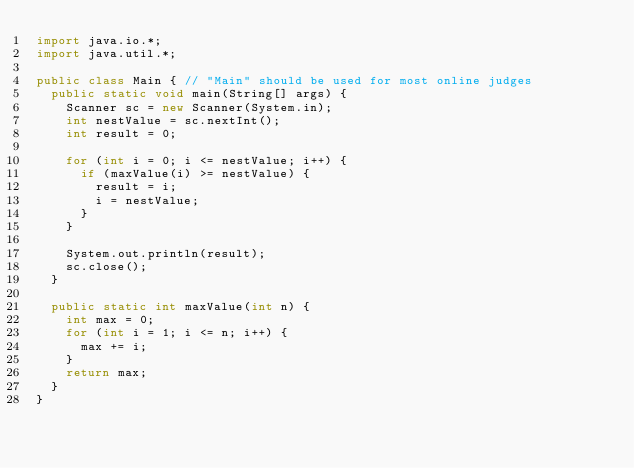Convert code to text. <code><loc_0><loc_0><loc_500><loc_500><_Java_>import java.io.*;
import java.util.*;

public class Main { // "Main" should be used for most online judges
	public static void main(String[] args) {
		Scanner sc = new Scanner(System.in);
		int nestValue = sc.nextInt();
		int result = 0;

		for (int i = 0; i <= nestValue; i++) {
			if (maxValue(i) >= nestValue) {
				result = i;
				i = nestValue;
			}
		}

		System.out.println(result);
		sc.close();
	}

	public static int maxValue(int n) {
		int max = 0;
		for (int i = 1; i <= n; i++) {
			max += i;
		}
		return max;
	}
}</code> 